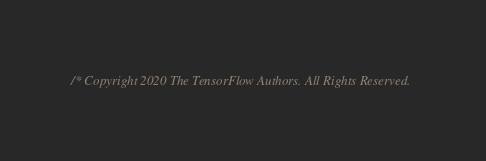<code> <loc_0><loc_0><loc_500><loc_500><_C++_>/* Copyright 2020 The TensorFlow Authors. All Rights Reserved.
</code> 